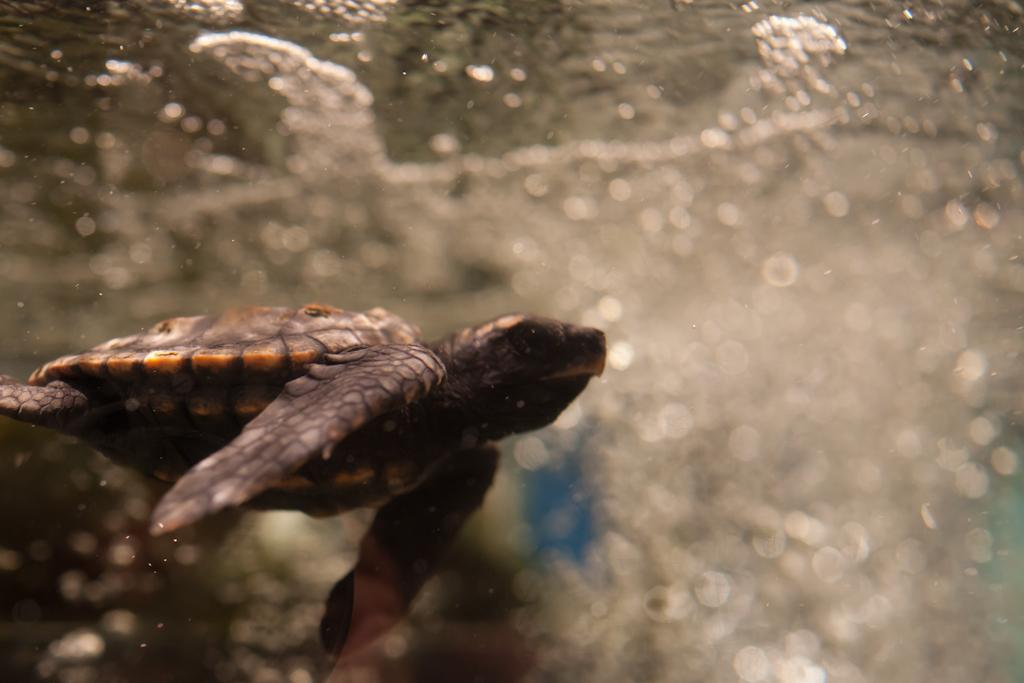What animal is present in the image? There is a turtle in the image. Where is the turtle located? The turtle is in the water. What might the turtle be doing in the water? The turtle might be swimming or resting in the water. What book is the turtle reading in the image? There is no book present in the image, and the turtle is not shown to be reading. 